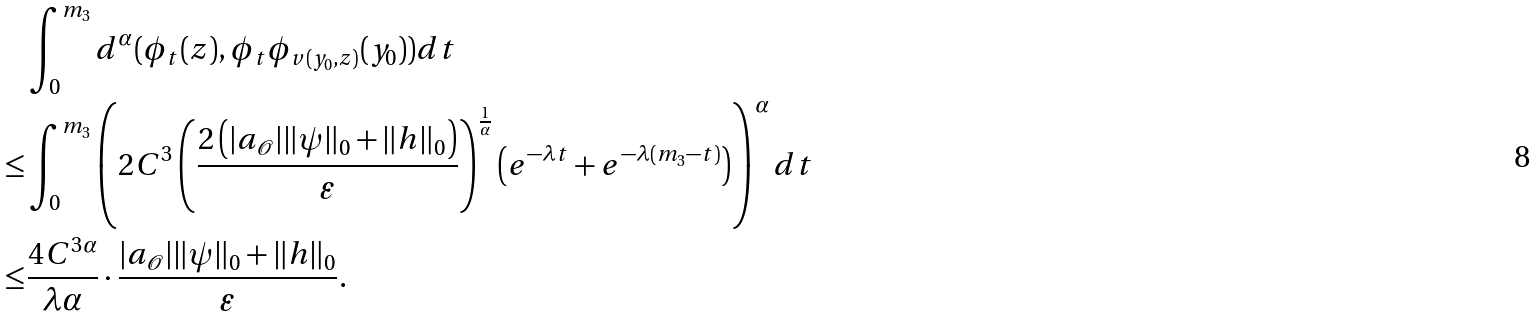Convert formula to latex. <formula><loc_0><loc_0><loc_500><loc_500>& \int _ { 0 } ^ { m _ { 3 } } d ^ { \alpha } ( \phi _ { t } ( z ) , \phi _ { t } \phi _ { v ( y _ { 0 } , z ) } ( y _ { 0 } ) ) d t \\ \leq & \int _ { 0 } ^ { m _ { 3 } } \left ( 2 C ^ { 3 } \left ( \frac { 2 \left ( | a _ { \mathcal { O } } | \| \psi \| _ { 0 } + \| h \| _ { 0 } \right ) } { \varepsilon } \right ) ^ { \frac { 1 } { \alpha } } \left ( e ^ { - \lambda t } + e ^ { - \lambda ( m _ { 3 } - t ) } \right ) \right ) ^ { \alpha } d t \\ \leq & \frac { 4 C ^ { 3 \alpha } } { \lambda \alpha } \cdot \frac { | a _ { \mathcal { O } } | \| \psi \| _ { 0 } + \| h \| _ { 0 } } { \varepsilon } .</formula> 